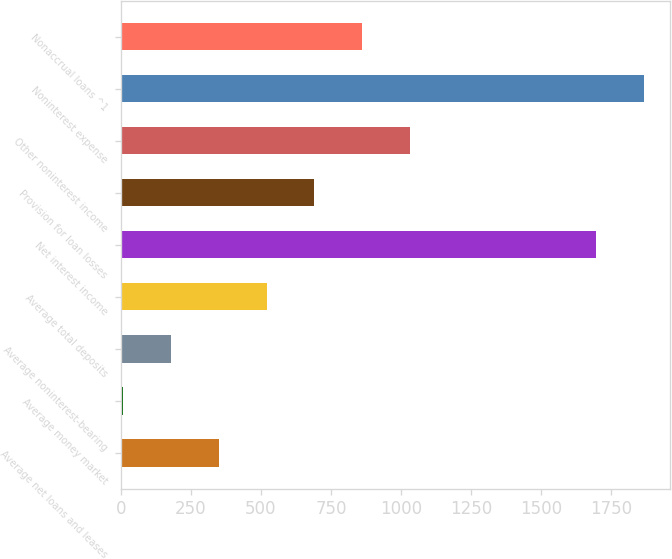<chart> <loc_0><loc_0><loc_500><loc_500><bar_chart><fcel>Average net loans and leases<fcel>Average money market<fcel>Average noninterest-bearing<fcel>Average total deposits<fcel>Net interest income<fcel>Provision for loan losses<fcel>Other noninterest income<fcel>Noninterest expense<fcel>Nonaccrual loans ^1<nl><fcel>349.92<fcel>8.8<fcel>179.36<fcel>520.48<fcel>1696.3<fcel>691.04<fcel>1032.16<fcel>1866.86<fcel>861.6<nl></chart> 